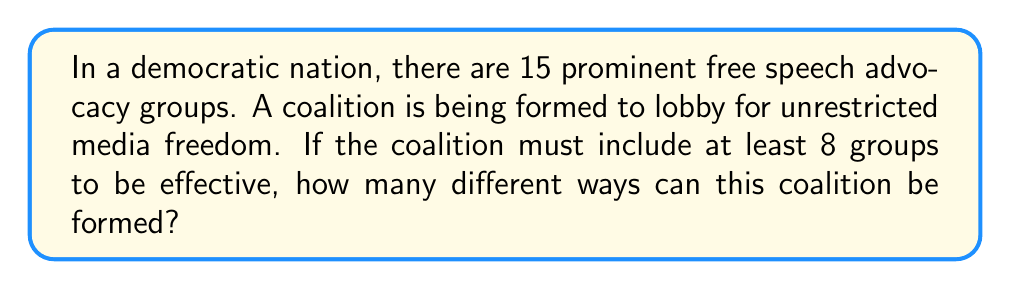What is the answer to this math problem? To solve this problem, we need to consider all possible coalition sizes from 8 to 15 groups and sum up the number of ways to select each size.

Let's break it down step by step:

1) We can use the combination formula to calculate the number of ways to select groups for each coalition size. The formula is:

   $${n \choose k} = \frac{n!}{k!(n-k)!}$$

   where $n$ is the total number of groups (15) and $k$ is the number of groups in the coalition.

2) We need to calculate this for $k = 8, 9, 10, 11, 12, 13, 14,$ and $15$.

3) Let's calculate each:

   For 8 groups: $${15 \choose 8} = \frac{15!}{8!(15-8)!} = \frac{15!}{8!7!} = 6435$$

   For 9 groups: $${15 \choose 9} = \frac{15!}{9!(15-9)!} = \frac{15!}{9!6!} = 5005$$

   For 10 groups: $${15 \choose 10} = \frac{15!}{10!(15-10)!} = \frac{15!}{10!5!} = 3003$$

   For 11 groups: $${15 \choose 11} = \frac{15!}{11!(15-11)!} = \frac{15!}{11!4!} = 1365$$

   For 12 groups: $${15 \choose 12} = \frac{15!}{12!(15-12)!} = \frac{15!}{12!3!} = 455$$

   For 13 groups: $${15 \choose 13} = \frac{15!}{13!(15-13)!} = \frac{15!}{13!2!} = 105$$

   For 14 groups: $${15 \choose 14} = \frac{15!}{14!(15-14)!} = \frac{15!}{14!1!} = 15$$

   For 15 groups: $${15 \choose 15} = \frac{15!}{15!(15-15)!} = \frac{15!}{15!0!} = 1$$

4) The total number of ways to form the coalition is the sum of all these combinations:

   $$6435 + 5005 + 3003 + 1365 + 455 + 105 + 15 + 1 = 16384$$

Therefore, there are 16384 different ways to form the coalition.
Answer: 16384 